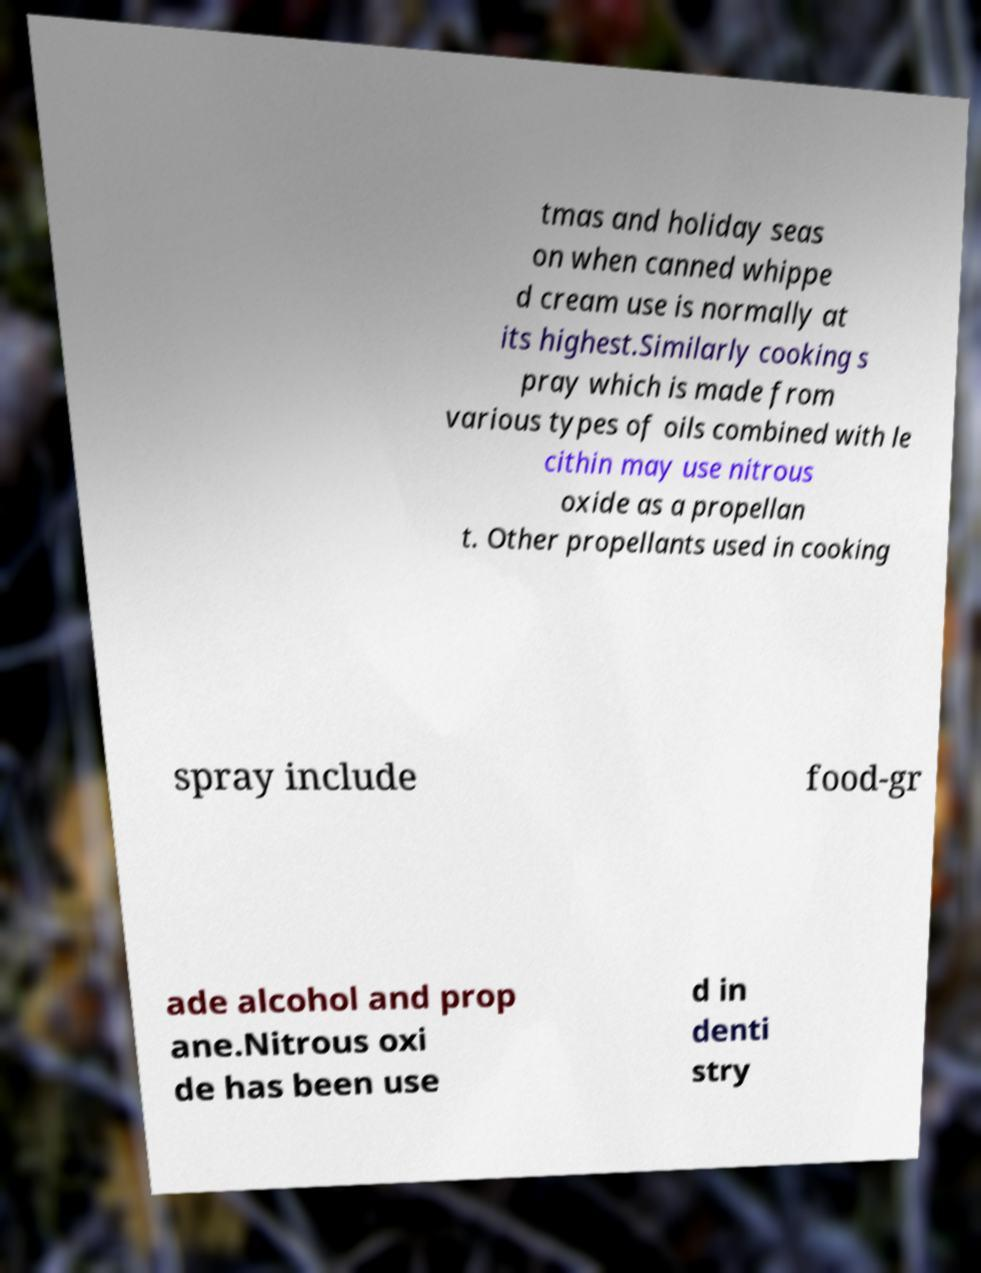Please identify and transcribe the text found in this image. tmas and holiday seas on when canned whippe d cream use is normally at its highest.Similarly cooking s pray which is made from various types of oils combined with le cithin may use nitrous oxide as a propellan t. Other propellants used in cooking spray include food-gr ade alcohol and prop ane.Nitrous oxi de has been use d in denti stry 